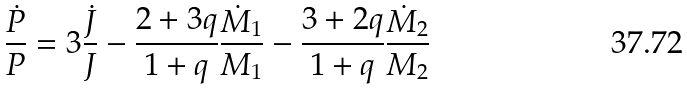<formula> <loc_0><loc_0><loc_500><loc_500>\frac { \dot { P } } { P } = 3 \frac { \dot { J } } { J } - \frac { 2 + 3 q } { 1 + q } \frac { \dot { M } _ { 1 } } { M _ { 1 } } - \frac { 3 + 2 q } { 1 + q } \frac { \dot { M } _ { 2 } } { M _ { 2 } }</formula> 